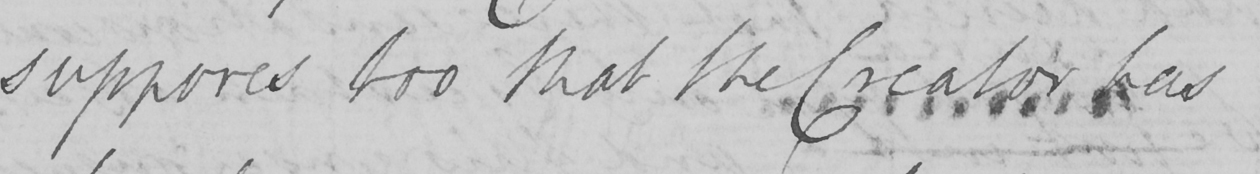What does this handwritten line say? supposes too that the Creator has 